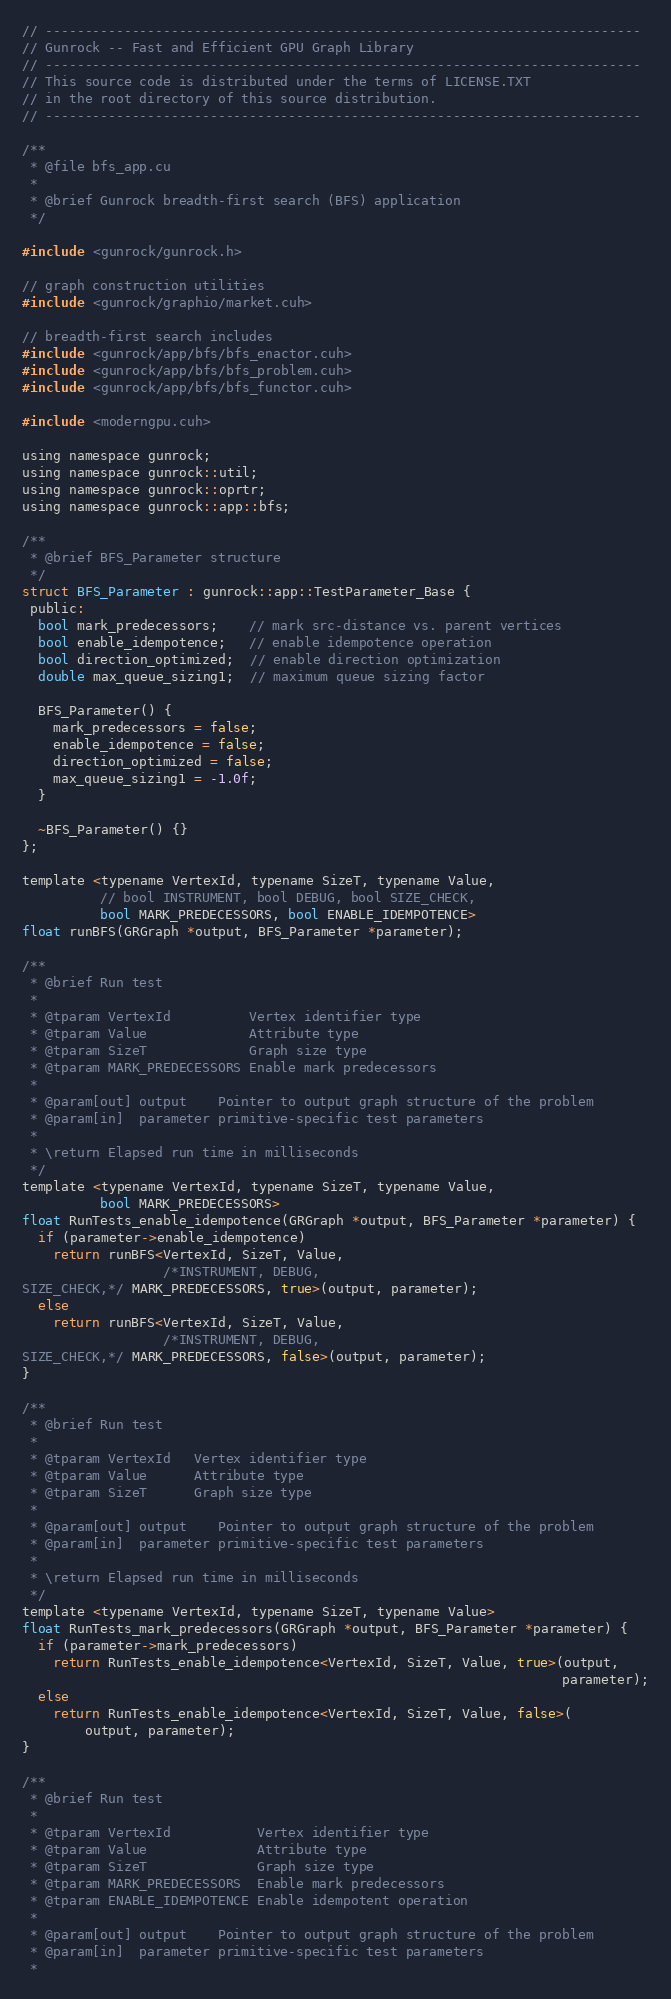<code> <loc_0><loc_0><loc_500><loc_500><_Cuda_>// ----------------------------------------------------------------------------
// Gunrock -- Fast and Efficient GPU Graph Library
// ----------------------------------------------------------------------------
// This source code is distributed under the terms of LICENSE.TXT
// in the root directory of this source distribution.
// ----------------------------------------------------------------------------

/**
 * @file bfs_app.cu
 *
 * @brief Gunrock breadth-first search (BFS) application
 */

#include <gunrock/gunrock.h>

// graph construction utilities
#include <gunrock/graphio/market.cuh>

// breadth-first search includes
#include <gunrock/app/bfs/bfs_enactor.cuh>
#include <gunrock/app/bfs/bfs_problem.cuh>
#include <gunrock/app/bfs/bfs_functor.cuh>

#include <moderngpu.cuh>

using namespace gunrock;
using namespace gunrock::util;
using namespace gunrock::oprtr;
using namespace gunrock::app::bfs;

/**
 * @brief BFS_Parameter structure
 */
struct BFS_Parameter : gunrock::app::TestParameter_Base {
 public:
  bool mark_predecessors;    // mark src-distance vs. parent vertices
  bool enable_idempotence;   // enable idempotence operation
  bool direction_optimized;  // enable direction optimization
  double max_queue_sizing1;  // maximum queue sizing factor

  BFS_Parameter() {
    mark_predecessors = false;
    enable_idempotence = false;
    direction_optimized = false;
    max_queue_sizing1 = -1.0f;
  }

  ~BFS_Parameter() {}
};

template <typename VertexId, typename SizeT, typename Value,
          // bool INSTRUMENT, bool DEBUG, bool SIZE_CHECK,
          bool MARK_PREDECESSORS, bool ENABLE_IDEMPOTENCE>
float runBFS(GRGraph *output, BFS_Parameter *parameter);

/**
 * @brief Run test
 *
 * @tparam VertexId          Vertex identifier type
 * @tparam Value             Attribute type
 * @tparam SizeT             Graph size type
 * @tparam MARK_PREDECESSORS Enable mark predecessors
 *
 * @param[out] output    Pointer to output graph structure of the problem
 * @param[in]  parameter primitive-specific test parameters
 *
 * \return Elapsed run time in milliseconds
 */
template <typename VertexId, typename SizeT, typename Value,
          bool MARK_PREDECESSORS>
float RunTests_enable_idempotence(GRGraph *output, BFS_Parameter *parameter) {
  if (parameter->enable_idempotence)
    return runBFS<VertexId, SizeT, Value,
                  /*INSTRUMENT, DEBUG,
SIZE_CHECK,*/ MARK_PREDECESSORS, true>(output, parameter);
  else
    return runBFS<VertexId, SizeT, Value,
                  /*INSTRUMENT, DEBUG,
SIZE_CHECK,*/ MARK_PREDECESSORS, false>(output, parameter);
}

/**
 * @brief Run test
 *
 * @tparam VertexId   Vertex identifier type
 * @tparam Value      Attribute type
 * @tparam SizeT      Graph size type
 *
 * @param[out] output    Pointer to output graph structure of the problem
 * @param[in]  parameter primitive-specific test parameters
 *
 * \return Elapsed run time in milliseconds
 */
template <typename VertexId, typename SizeT, typename Value>
float RunTests_mark_predecessors(GRGraph *output, BFS_Parameter *parameter) {
  if (parameter->mark_predecessors)
    return RunTests_enable_idempotence<VertexId, SizeT, Value, true>(output,
                                                                     parameter);
  else
    return RunTests_enable_idempotence<VertexId, SizeT, Value, false>(
        output, parameter);
}

/**
 * @brief Run test
 *
 * @tparam VertexId           Vertex identifier type
 * @tparam Value              Attribute type
 * @tparam SizeT              Graph size type
 * @tparam MARK_PREDECESSORS  Enable mark predecessors
 * @tparam ENABLE_IDEMPOTENCE Enable idempotent operation
 *
 * @param[out] output    Pointer to output graph structure of the problem
 * @param[in]  parameter primitive-specific test parameters
 *</code> 